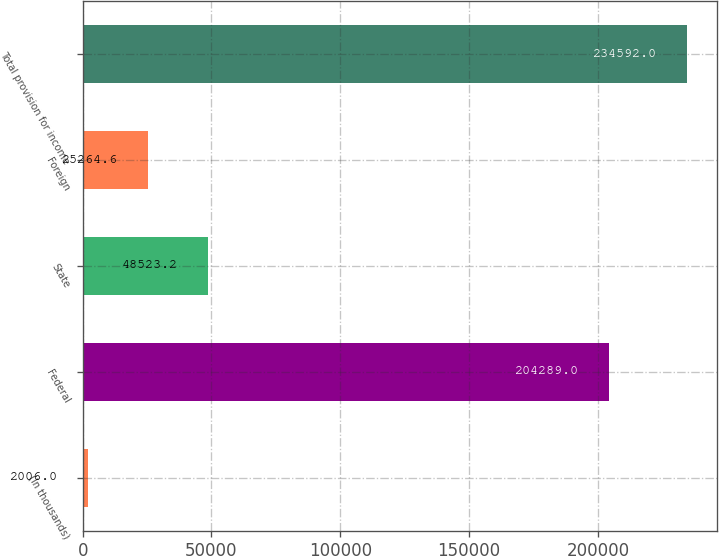<chart> <loc_0><loc_0><loc_500><loc_500><bar_chart><fcel>(In thousands)<fcel>Federal<fcel>State<fcel>Foreign<fcel>Total provision for income<nl><fcel>2006<fcel>204289<fcel>48523.2<fcel>25264.6<fcel>234592<nl></chart> 